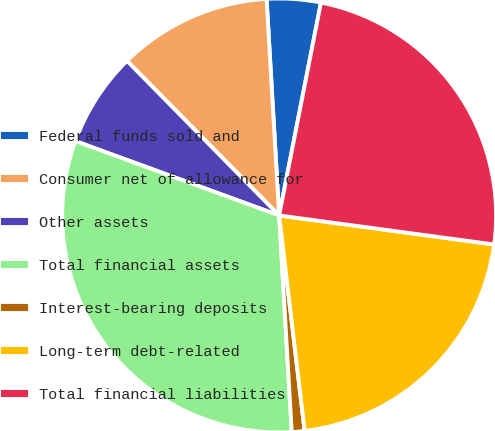<chart> <loc_0><loc_0><loc_500><loc_500><pie_chart><fcel>Federal funds sold and<fcel>Consumer net of allowance for<fcel>Other assets<fcel>Total financial assets<fcel>Interest-bearing deposits<fcel>Long-term debt-related<fcel>Total financial liabilities<nl><fcel>4.01%<fcel>11.45%<fcel>7.06%<fcel>31.49%<fcel>0.95%<fcel>20.99%<fcel>24.05%<nl></chart> 